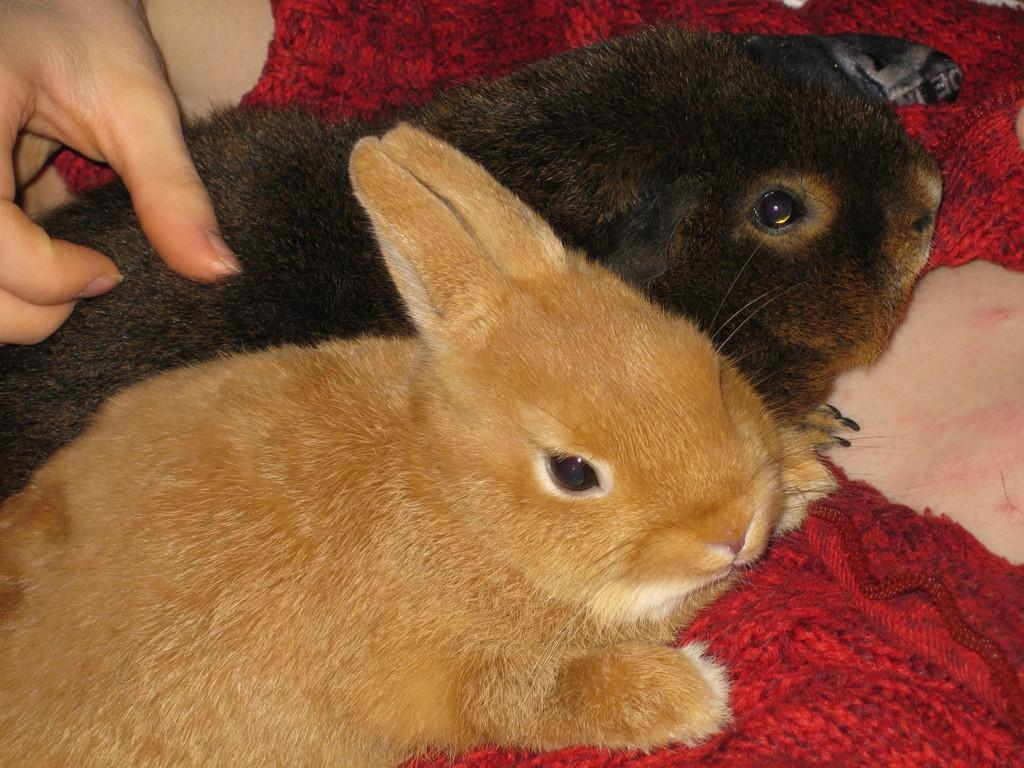What is the main subject of the image? The main subject of the image is a person sitting. What is the person holding in the image? The person is holding two rabbits. What type of meal is being prepared by the person in the image? There is no meal preparation visible in the image; the person is holding two rabbits. What color is the chalk used by the person in the image? There is no chalk present in the image; the person is holding two rabbits. 